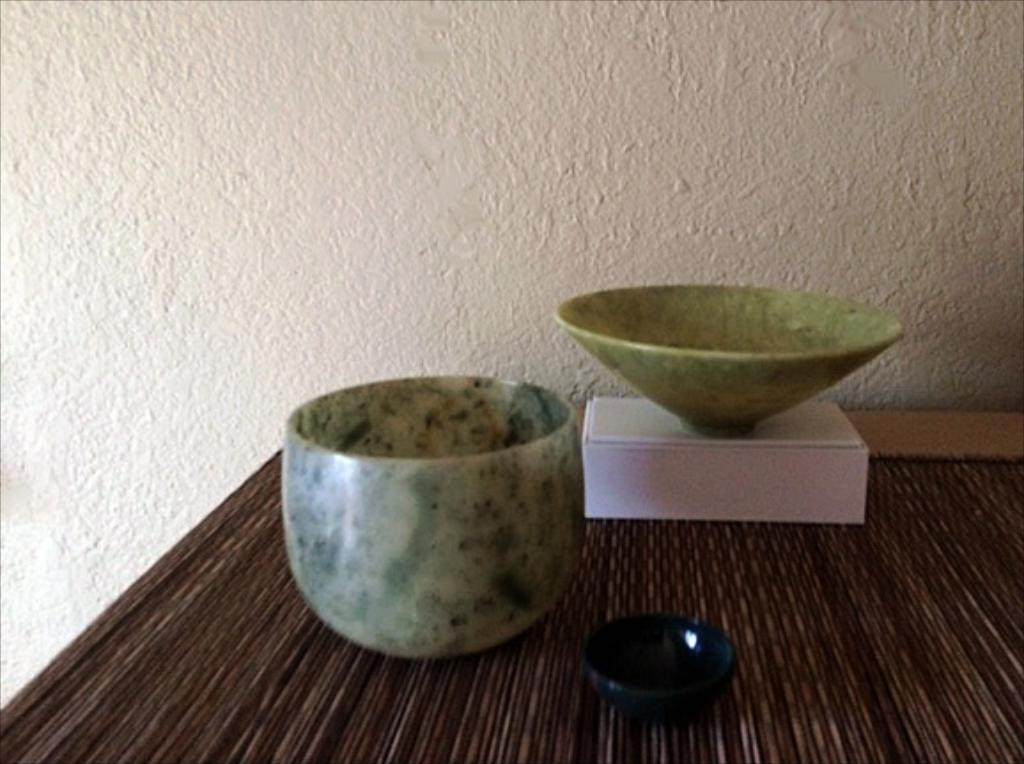What type of objects can be seen in the image? There are three ceramic objects in the image. What else is present on the table in the image? There is a box on the table in the image. What is visible behind the ceramic objects in the image? There is a wall behind the ceramic objects in the image. What type of cakes are being prepared on the table in the image? There are no cakes present in the image; it only features ceramic objects and a box on the table. 